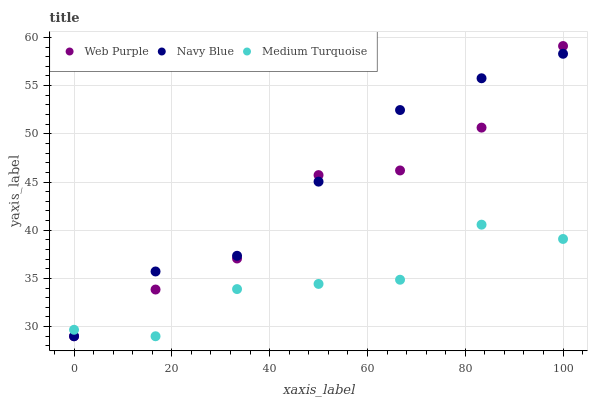Does Medium Turquoise have the minimum area under the curve?
Answer yes or no. Yes. Does Navy Blue have the maximum area under the curve?
Answer yes or no. Yes. Does Web Purple have the minimum area under the curve?
Answer yes or no. No. Does Web Purple have the maximum area under the curve?
Answer yes or no. No. Is Navy Blue the smoothest?
Answer yes or no. Yes. Is Web Purple the roughest?
Answer yes or no. Yes. Is Medium Turquoise the smoothest?
Answer yes or no. No. Is Medium Turquoise the roughest?
Answer yes or no. No. Does Navy Blue have the lowest value?
Answer yes or no. Yes. Does Web Purple have the highest value?
Answer yes or no. Yes. Does Medium Turquoise have the highest value?
Answer yes or no. No. Does Navy Blue intersect Web Purple?
Answer yes or no. Yes. Is Navy Blue less than Web Purple?
Answer yes or no. No. Is Navy Blue greater than Web Purple?
Answer yes or no. No. 